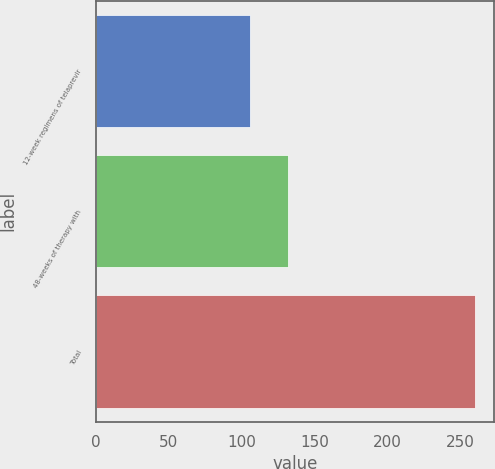<chart> <loc_0><loc_0><loc_500><loc_500><bar_chart><fcel>12-week regimens of telaprevir<fcel>48-weeks of therapy with<fcel>Total<nl><fcel>105.81<fcel>131.62<fcel>260<nl></chart> 